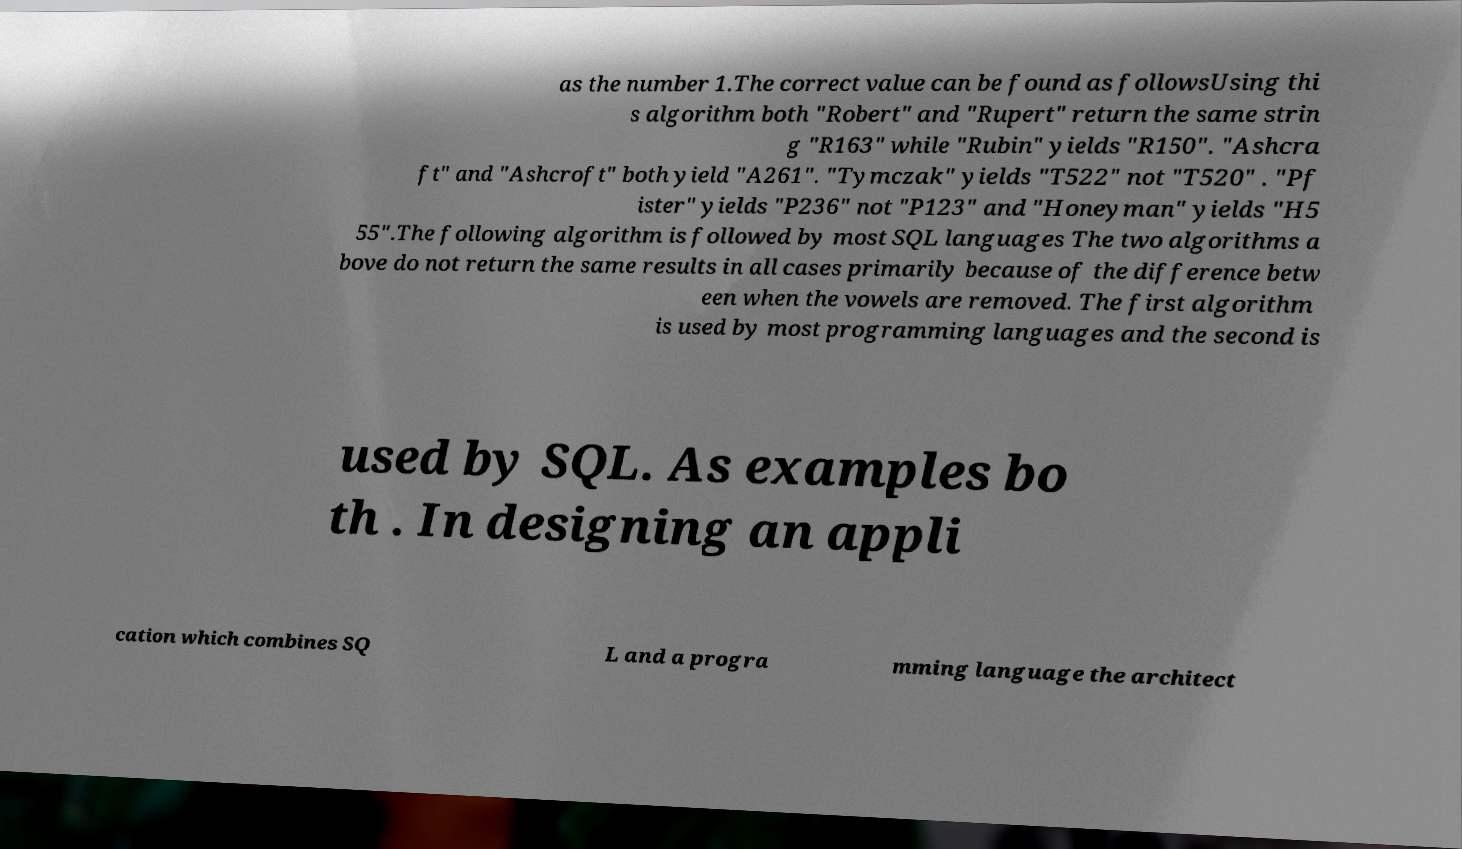Could you extract and type out the text from this image? as the number 1.The correct value can be found as followsUsing thi s algorithm both "Robert" and "Rupert" return the same strin g "R163" while "Rubin" yields "R150". "Ashcra ft" and "Ashcroft" both yield "A261". "Tymczak" yields "T522" not "T520" . "Pf ister" yields "P236" not "P123" and "Honeyman" yields "H5 55".The following algorithm is followed by most SQL languages The two algorithms a bove do not return the same results in all cases primarily because of the difference betw een when the vowels are removed. The first algorithm is used by most programming languages and the second is used by SQL. As examples bo th . In designing an appli cation which combines SQ L and a progra mming language the architect 